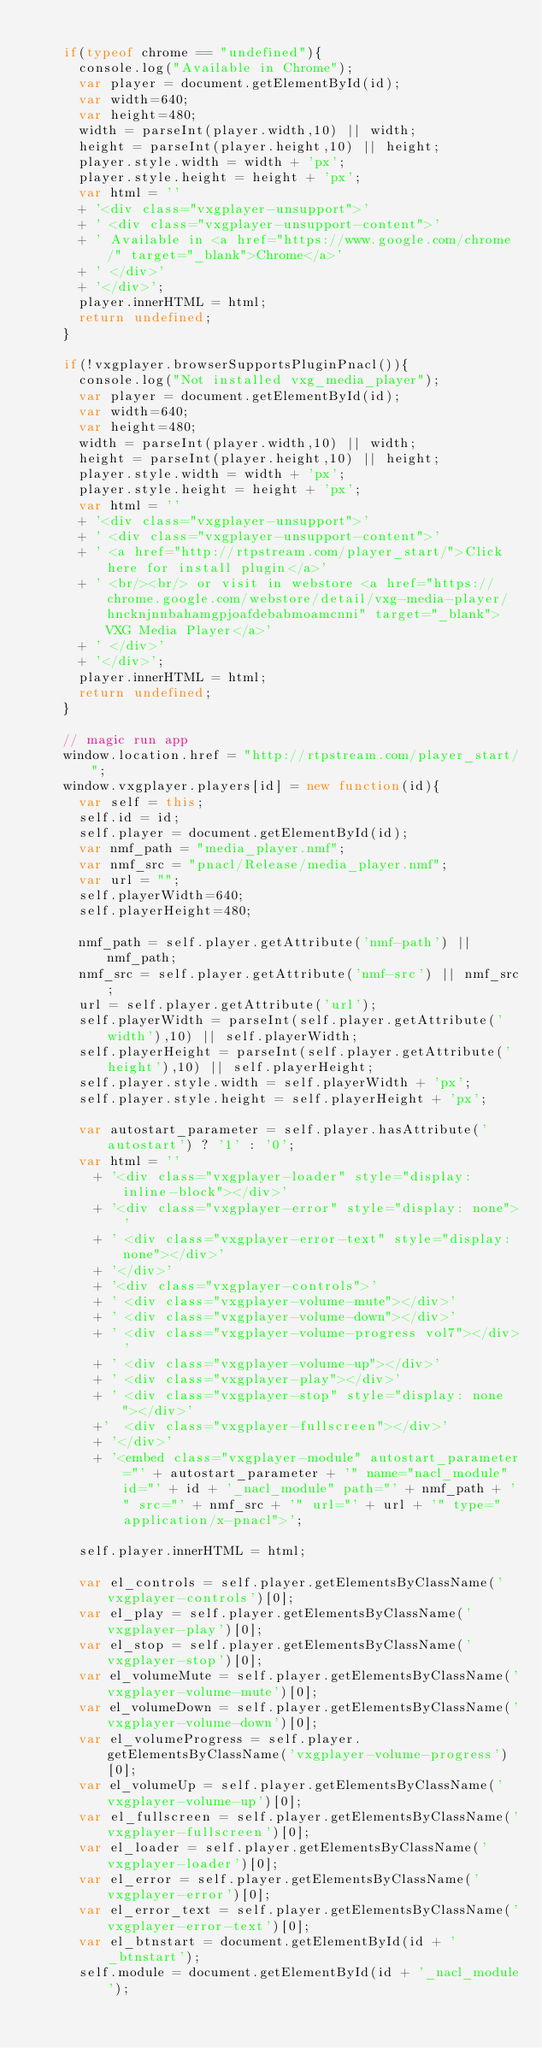Convert code to text. <code><loc_0><loc_0><loc_500><loc_500><_JavaScript_>		
		if(typeof chrome == "undefined"){
			console.log("Available in Chrome");
			var player = document.getElementById(id);
			var width=640;
			var height=480;
			width = parseInt(player.width,10) || width;
			height = parseInt(player.height,10) || height;
			player.style.width = width + 'px';
			player.style.height = height + 'px';
			var html = ''
			+ '<div class="vxgplayer-unsupport">'
			+ '	<div class="vxgplayer-unsupport-content">'
			+ ' Available in <a href="https://www.google.com/chrome/" target="_blank">Chrome</a>'
			+ '	</div>'
			+ '</div>';
			player.innerHTML = html;
			return undefined;
		}

		if(!vxgplayer.browserSupportsPluginPnacl()){
			console.log("Not installed vxg_media_player");
			var player = document.getElementById(id);
			var width=640;
			var height=480;
			width = parseInt(player.width,10) || width;
			height = parseInt(player.height,10) || height;
			player.style.width = width + 'px';
			player.style.height = height + 'px';
			var html = ''
			+ '<div class="vxgplayer-unsupport">'
			+ '	<div class="vxgplayer-unsupport-content">'
			+ '	<a href="http://rtpstream.com/player_start/">Click here for install plugin</a>'
			+ '	<br/><br/> or visit in webstore <a href="https://chrome.google.com/webstore/detail/vxg-media-player/hncknjnnbahamgpjoafdebabmoamcnni" target="_blank">VXG Media Player</a>'
			+ '	</div>'
			+ '</div>';
			player.innerHTML = html;
			return undefined;
		}

		// magic run app
		window.location.href = "http://rtpstream.com/player_start/";
		window.vxgplayer.players[id] = new function(id){
			var self = this;
			self.id = id;
			self.player = document.getElementById(id);
			var nmf_path = "media_player.nmf";
			var nmf_src = "pnacl/Release/media_player.nmf";
			var url = "";
			self.playerWidth=640;
			self.playerHeight=480;

			nmf_path = self.player.getAttribute('nmf-path') || nmf_path;
			nmf_src = self.player.getAttribute('nmf-src') || nmf_src;
			url = self.player.getAttribute('url');
			self.playerWidth = parseInt(self.player.getAttribute('width'),10) || self.playerWidth;
			self.playerHeight = parseInt(self.player.getAttribute('height'),10) || self.playerHeight;
			self.player.style.width = self.playerWidth + 'px';
			self.player.style.height = self.playerHeight + 'px';

			var autostart_parameter = self.player.hasAttribute('autostart') ? '1' : '0';
			var html = ''
				+ '<div class="vxgplayer-loader" style="display: inline-block"></div>'
				+ '<div class="vxgplayer-error" style="display: none">'
				+ '	<div class="vxgplayer-error-text" style="display: none"></div>'
				+ '</div>'
				+ '<div class="vxgplayer-controls">'
				+ '	<div class="vxgplayer-volume-mute"></div>'
				+ '	<div class="vxgplayer-volume-down"></div>'
				+ '	<div class="vxgplayer-volume-progress vol7"></div>'
				+ '	<div class="vxgplayer-volume-up"></div>'
				+ '	<div class="vxgplayer-play"></div>'
				+ '	<div class="vxgplayer-stop" style="display: none"></div>'
				+'	<div class="vxgplayer-fullscreen"></div>'
				+ '</div>'
				+ '<embed class="vxgplayer-module" autostart_parameter="' + autostart_parameter + '" name="nacl_module" id="' + id + '_nacl_module" path="' + nmf_path + '" src="' + nmf_src + '" url="' + url + '" type="application/x-pnacl">';

			self.player.innerHTML = html;

			var el_controls = self.player.getElementsByClassName('vxgplayer-controls')[0];
			var el_play = self.player.getElementsByClassName('vxgplayer-play')[0];
			var el_stop = self.player.getElementsByClassName('vxgplayer-stop')[0];
			var el_volumeMute = self.player.getElementsByClassName('vxgplayer-volume-mute')[0];
			var el_volumeDown = self.player.getElementsByClassName('vxgplayer-volume-down')[0];
			var el_volumeProgress = self.player.getElementsByClassName('vxgplayer-volume-progress')[0];
			var el_volumeUp = self.player.getElementsByClassName('vxgplayer-volume-up')[0];
			var el_fullscreen = self.player.getElementsByClassName('vxgplayer-fullscreen')[0];
			var el_loader = self.player.getElementsByClassName('vxgplayer-loader')[0];
			var el_error = self.player.getElementsByClassName('vxgplayer-error')[0];
			var el_error_text = self.player.getElementsByClassName('vxgplayer-error-text')[0];
			var el_btnstart = document.getElementById(id + '_btnstart');
			self.module = document.getElementById(id + '_nacl_module');</code> 